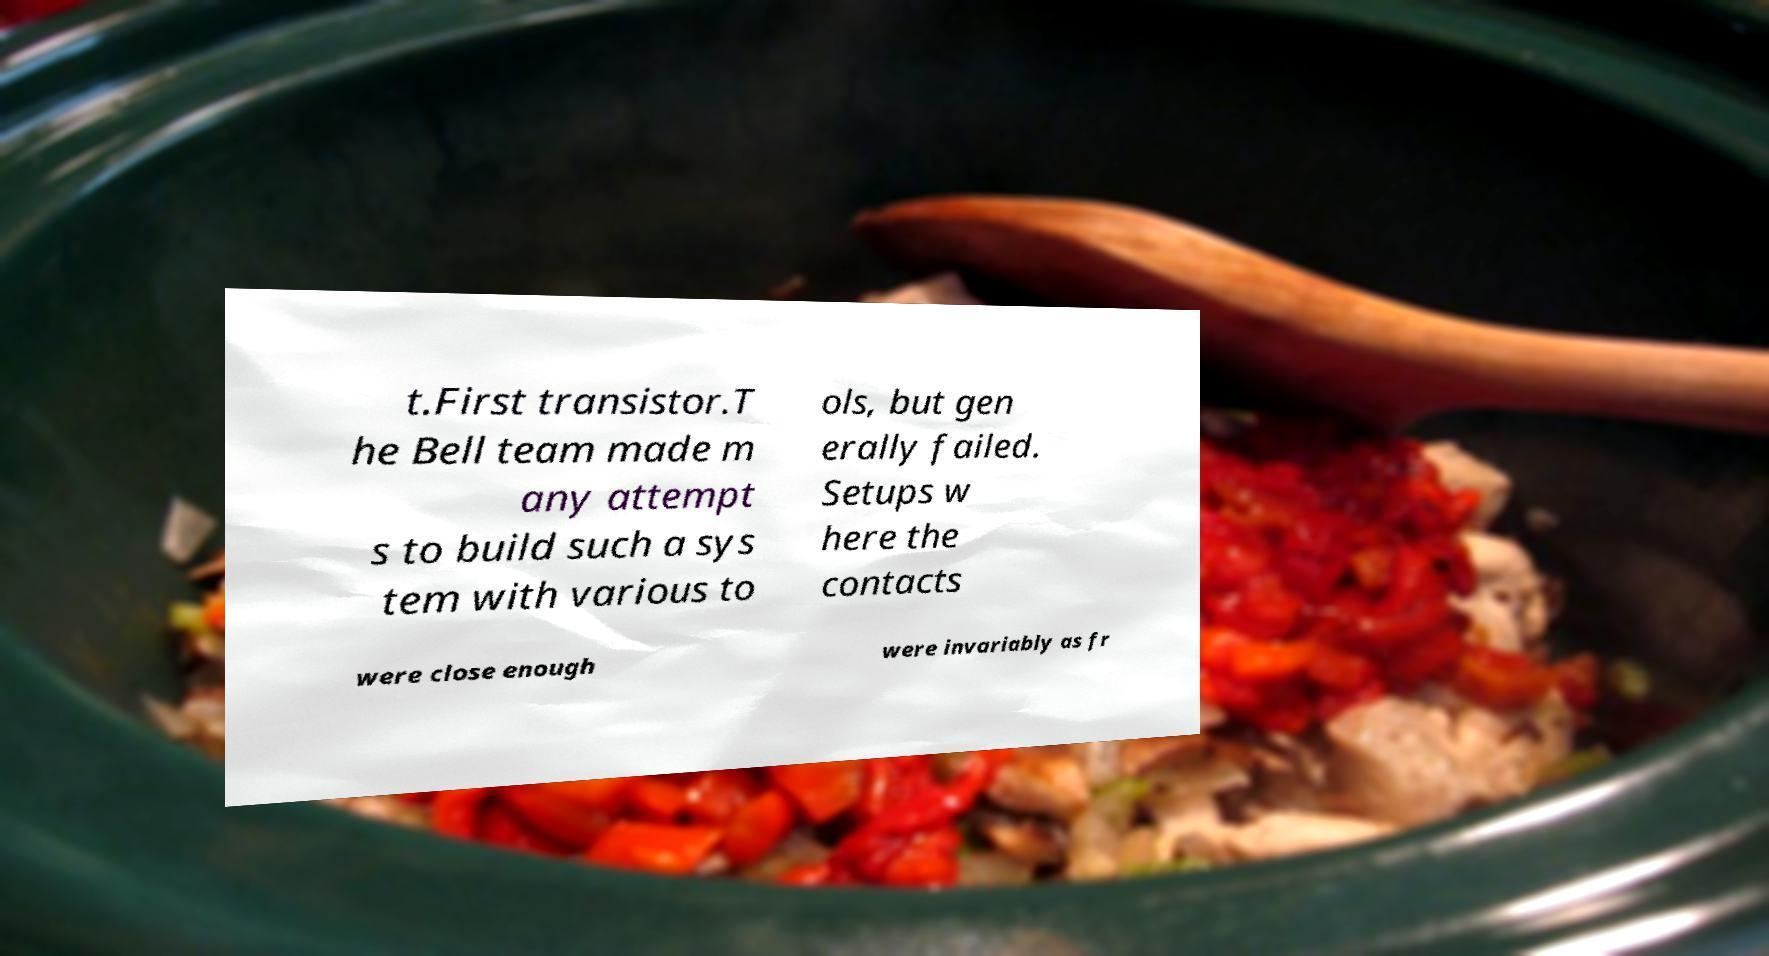I need the written content from this picture converted into text. Can you do that? t.First transistor.T he Bell team made m any attempt s to build such a sys tem with various to ols, but gen erally failed. Setups w here the contacts were close enough were invariably as fr 